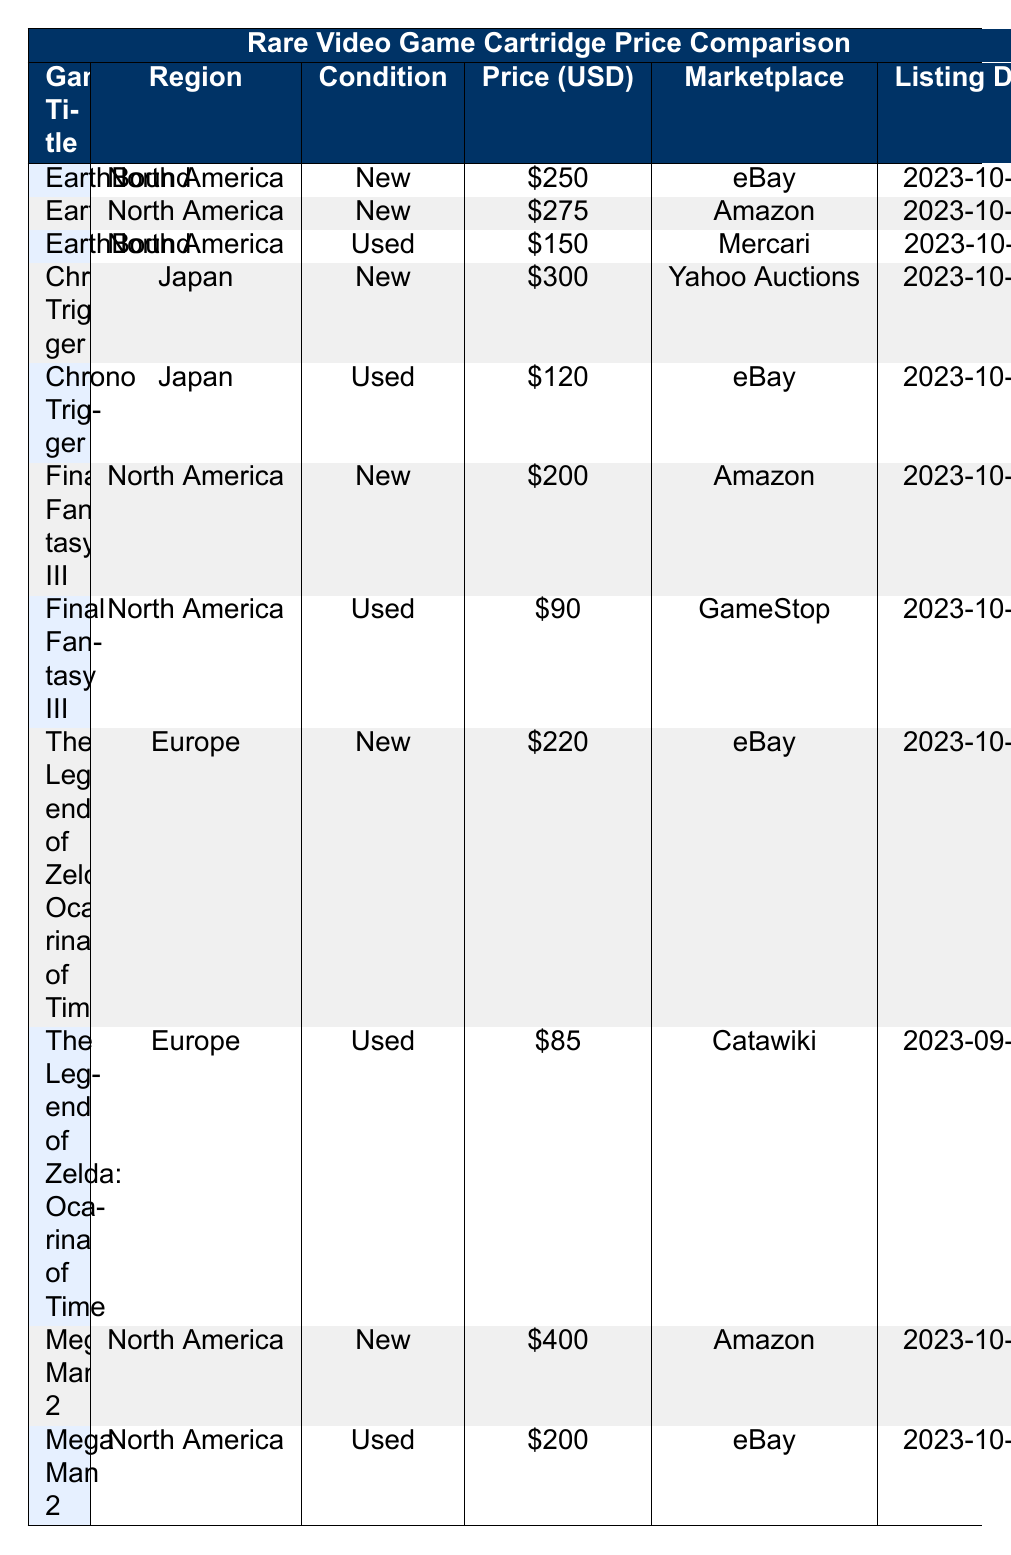What is the price of a new version of EarthBound on eBay? The table indicates that the price of a new version of EarthBound on eBay is listed as 250 USD in the row that specifies both the condition as New and the marketplace as eBay.
Answer: 250 Which marketplace offers the lowest price for Final Fantasy III? The table shows two prices for Final Fantasy III: 200 USD on Amazon (New) and 90 USD on GameStop (Used). The lowest price is found on GameStop for the Used condition.
Answer: GameStop What is the price difference between the new and used versions of Chrono Trigger? The new version of Chrono Trigger is priced at 300 USD and the used version is 120 USD. The price difference is calculated as 300 USD - 120 USD = 180 USD.
Answer: 180 Is there a used version of Mega Man 2 available on eBay? According to the table, the used version of Mega Man 2 is not listed on eBay; it is listed as 200 USD on eBay, but that is for the New condition. Thus, the answer is no.
Answer: No What is the average price of used video game cartridges listed in the table? The used prices are 150 USD (EarthBound), 120 USD (Chrono Trigger), 90 USD (Final Fantasy III), 85 USD (The Legend of Zelda: Ocarina of Time), and 200 USD (Mega Man 2). The sum is 645 USD, and there are 5 used listings, so the average price is 645 USD / 5 = 129 USD.
Answer: 129 Which game has the highest price in a New condition? The table lists Mega Man 2 as a New condition game priced at 400 USD, which is higher compared to other New conditions: EarthBound at 250 USD, Chrono Trigger at 300 USD, Final Fantasy III at 200 USD, and The Legend of Zelda: Ocarina of Time at 220 USD. Hence, Mega Man 2 has the highest price.
Answer: Mega Man 2 What marketplace has the highest number of listings for game cartridges? Each marketplace in the table is counted: eBay has 3 (EarthBound, Chrono Trigger, and Mega Man 2), Amazon has 2 (EarthBound and Final Fantasy III), Mercari has 1 (EarthBound), Yahoo Auctions has 1 (Chrono Trigger), GameStop has 1 (Final Fantasy III), Catawiki has 1 (The Legend of Zelda: Ocarina of Time). eBay has the most listings, with 3.
Answer: eBay What is the price of the used version of The Legend of Zelda: Ocarina of Time? Referring to the table, the price listed for the used version of The Legend of Zelda: Ocarina of Time is 85 USD, as specified in the row that indicates the condition as Used.
Answer: 85 